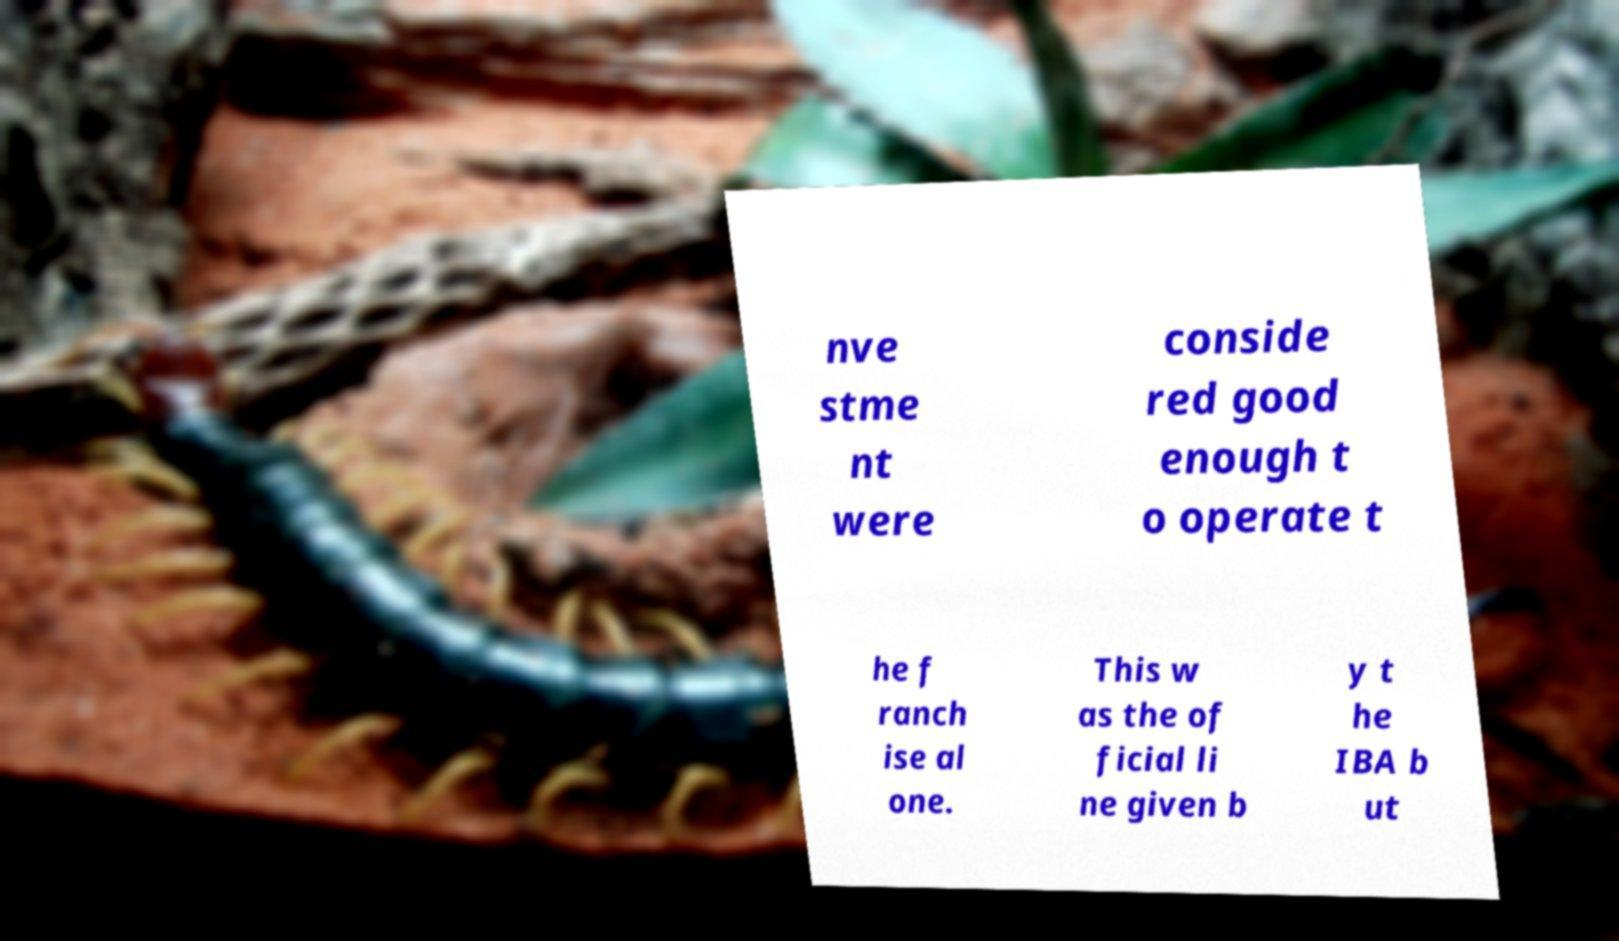What messages or text are displayed in this image? I need them in a readable, typed format. nve stme nt were conside red good enough t o operate t he f ranch ise al one. This w as the of ficial li ne given b y t he IBA b ut 